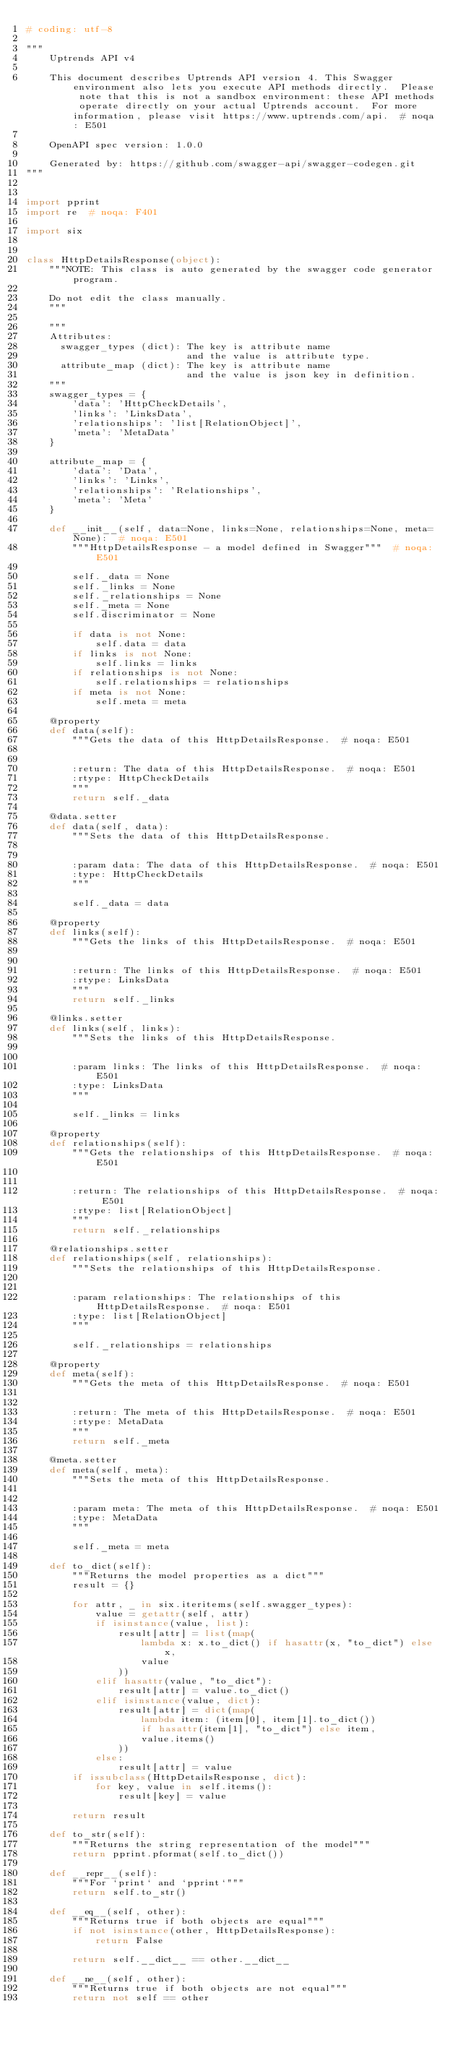<code> <loc_0><loc_0><loc_500><loc_500><_Python_># coding: utf-8

"""
    Uptrends API v4

    This document describes Uptrends API version 4. This Swagger environment also lets you execute API methods directly.  Please note that this is not a sandbox environment: these API methods operate directly on your actual Uptrends account.  For more information, please visit https://www.uptrends.com/api.  # noqa: E501

    OpenAPI spec version: 1.0.0
    
    Generated by: https://github.com/swagger-api/swagger-codegen.git
"""


import pprint
import re  # noqa: F401

import six


class HttpDetailsResponse(object):
    """NOTE: This class is auto generated by the swagger code generator program.

    Do not edit the class manually.
    """

    """
    Attributes:
      swagger_types (dict): The key is attribute name
                            and the value is attribute type.
      attribute_map (dict): The key is attribute name
                            and the value is json key in definition.
    """
    swagger_types = {
        'data': 'HttpCheckDetails',
        'links': 'LinksData',
        'relationships': 'list[RelationObject]',
        'meta': 'MetaData'
    }

    attribute_map = {
        'data': 'Data',
        'links': 'Links',
        'relationships': 'Relationships',
        'meta': 'Meta'
    }

    def __init__(self, data=None, links=None, relationships=None, meta=None):  # noqa: E501
        """HttpDetailsResponse - a model defined in Swagger"""  # noqa: E501

        self._data = None
        self._links = None
        self._relationships = None
        self._meta = None
        self.discriminator = None

        if data is not None:
            self.data = data
        if links is not None:
            self.links = links
        if relationships is not None:
            self.relationships = relationships
        if meta is not None:
            self.meta = meta

    @property
    def data(self):
        """Gets the data of this HttpDetailsResponse.  # noqa: E501


        :return: The data of this HttpDetailsResponse.  # noqa: E501
        :rtype: HttpCheckDetails
        """
        return self._data

    @data.setter
    def data(self, data):
        """Sets the data of this HttpDetailsResponse.


        :param data: The data of this HttpDetailsResponse.  # noqa: E501
        :type: HttpCheckDetails
        """

        self._data = data

    @property
    def links(self):
        """Gets the links of this HttpDetailsResponse.  # noqa: E501


        :return: The links of this HttpDetailsResponse.  # noqa: E501
        :rtype: LinksData
        """
        return self._links

    @links.setter
    def links(self, links):
        """Sets the links of this HttpDetailsResponse.


        :param links: The links of this HttpDetailsResponse.  # noqa: E501
        :type: LinksData
        """

        self._links = links

    @property
    def relationships(self):
        """Gets the relationships of this HttpDetailsResponse.  # noqa: E501


        :return: The relationships of this HttpDetailsResponse.  # noqa: E501
        :rtype: list[RelationObject]
        """
        return self._relationships

    @relationships.setter
    def relationships(self, relationships):
        """Sets the relationships of this HttpDetailsResponse.


        :param relationships: The relationships of this HttpDetailsResponse.  # noqa: E501
        :type: list[RelationObject]
        """

        self._relationships = relationships

    @property
    def meta(self):
        """Gets the meta of this HttpDetailsResponse.  # noqa: E501


        :return: The meta of this HttpDetailsResponse.  # noqa: E501
        :rtype: MetaData
        """
        return self._meta

    @meta.setter
    def meta(self, meta):
        """Sets the meta of this HttpDetailsResponse.


        :param meta: The meta of this HttpDetailsResponse.  # noqa: E501
        :type: MetaData
        """

        self._meta = meta

    def to_dict(self):
        """Returns the model properties as a dict"""
        result = {}

        for attr, _ in six.iteritems(self.swagger_types):
            value = getattr(self, attr)
            if isinstance(value, list):
                result[attr] = list(map(
                    lambda x: x.to_dict() if hasattr(x, "to_dict") else x,
                    value
                ))
            elif hasattr(value, "to_dict"):
                result[attr] = value.to_dict()
            elif isinstance(value, dict):
                result[attr] = dict(map(
                    lambda item: (item[0], item[1].to_dict())
                    if hasattr(item[1], "to_dict") else item,
                    value.items()
                ))
            else:
                result[attr] = value
        if issubclass(HttpDetailsResponse, dict):
            for key, value in self.items():
                result[key] = value

        return result

    def to_str(self):
        """Returns the string representation of the model"""
        return pprint.pformat(self.to_dict())

    def __repr__(self):
        """For `print` and `pprint`"""
        return self.to_str()

    def __eq__(self, other):
        """Returns true if both objects are equal"""
        if not isinstance(other, HttpDetailsResponse):
            return False

        return self.__dict__ == other.__dict__

    def __ne__(self, other):
        """Returns true if both objects are not equal"""
        return not self == other
</code> 